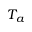<formula> <loc_0><loc_0><loc_500><loc_500>T _ { a }</formula> 